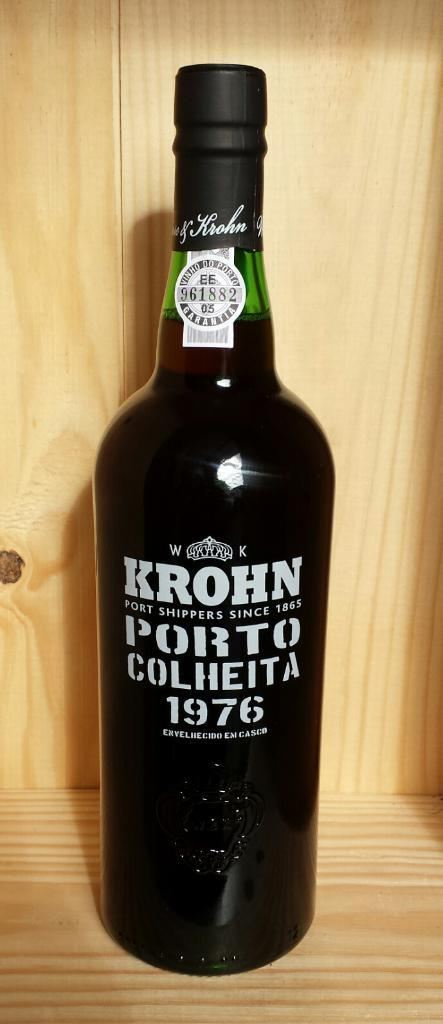Provide a one-sentence caption for the provided image. A bottle of Krohn sitting on a wooden shelf. 